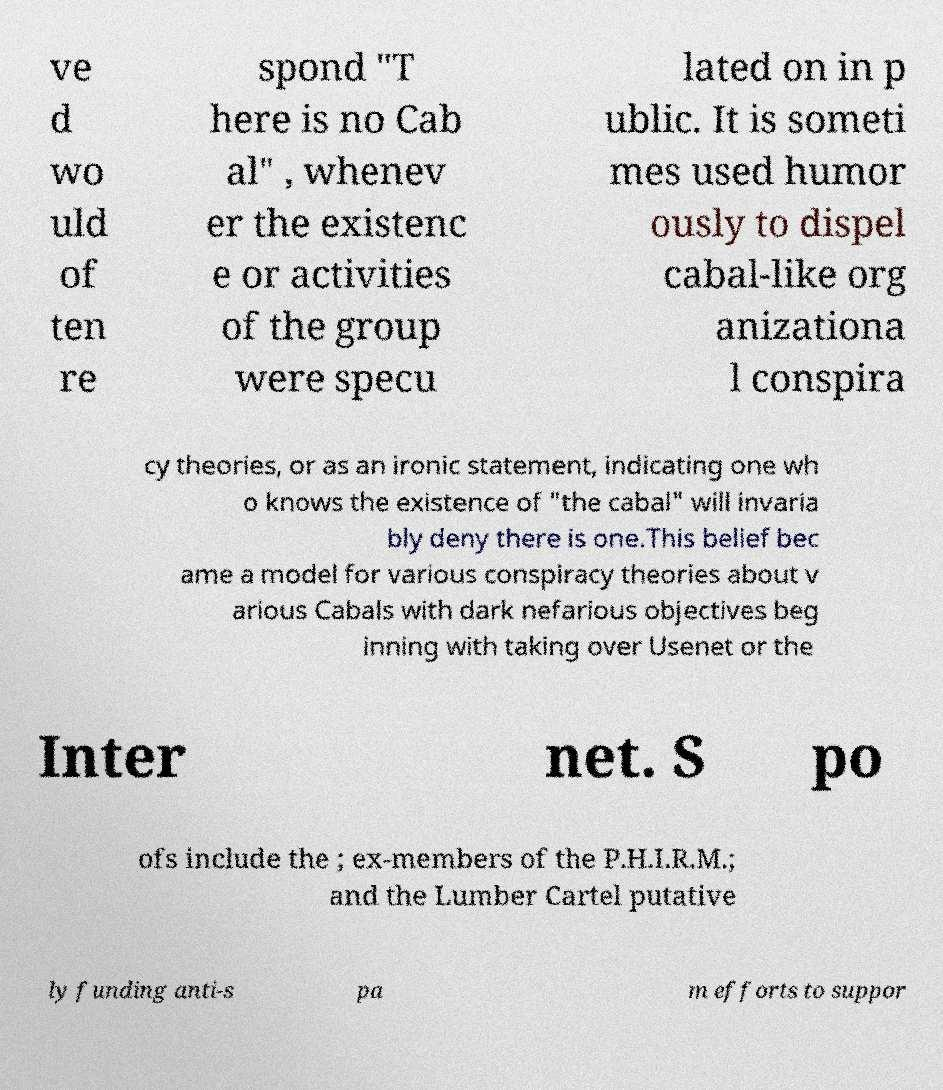Can you read and provide the text displayed in the image?This photo seems to have some interesting text. Can you extract and type it out for me? ve d wo uld of ten re spond "T here is no Cab al" , whenev er the existenc e or activities of the group were specu lated on in p ublic. It is someti mes used humor ously to dispel cabal-like org anizationa l conspira cy theories, or as an ironic statement, indicating one wh o knows the existence of "the cabal" will invaria bly deny there is one.This belief bec ame a model for various conspiracy theories about v arious Cabals with dark nefarious objectives beg inning with taking over Usenet or the Inter net. S po ofs include the ; ex-members of the P.H.I.R.M.; and the Lumber Cartel putative ly funding anti-s pa m efforts to suppor 